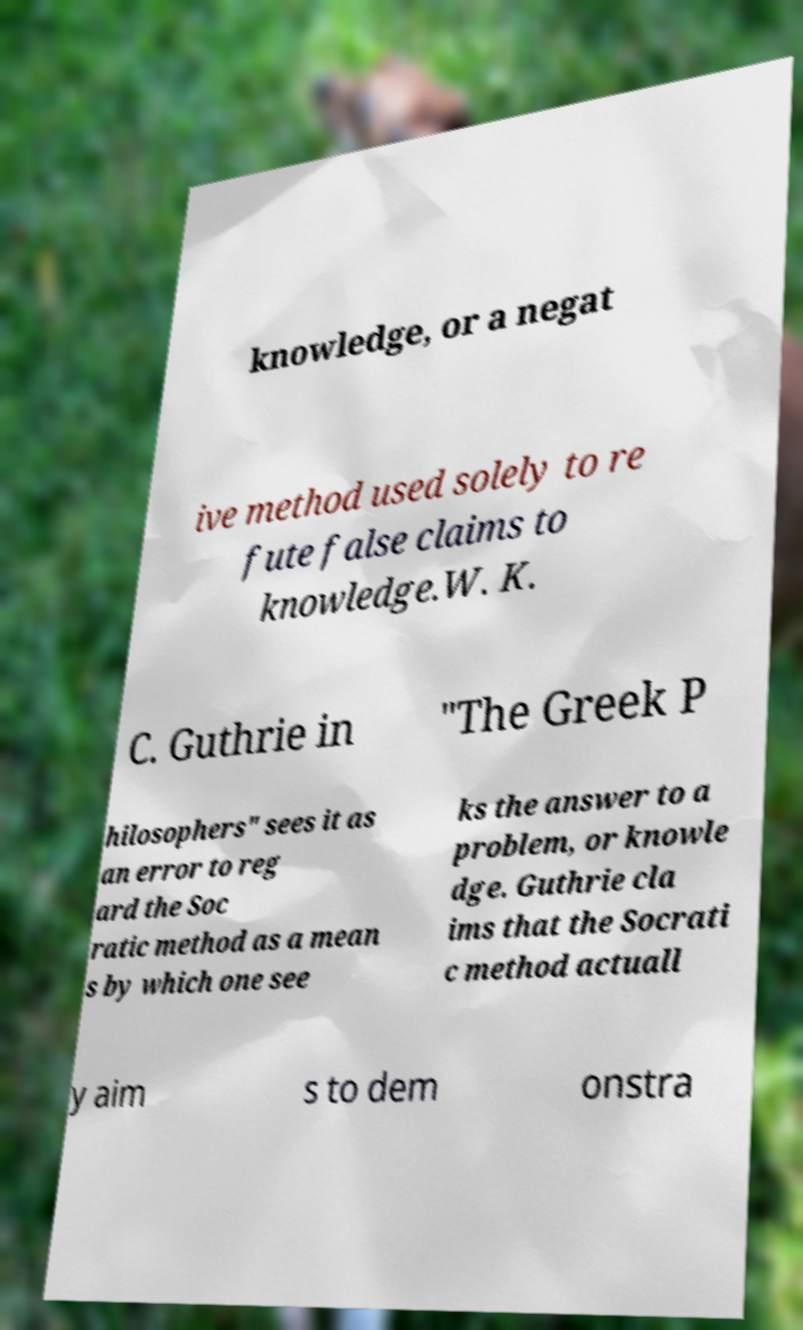I need the written content from this picture converted into text. Can you do that? knowledge, or a negat ive method used solely to re fute false claims to knowledge.W. K. C. Guthrie in "The Greek P hilosophers" sees it as an error to reg ard the Soc ratic method as a mean s by which one see ks the answer to a problem, or knowle dge. Guthrie cla ims that the Socrati c method actuall y aim s to dem onstra 